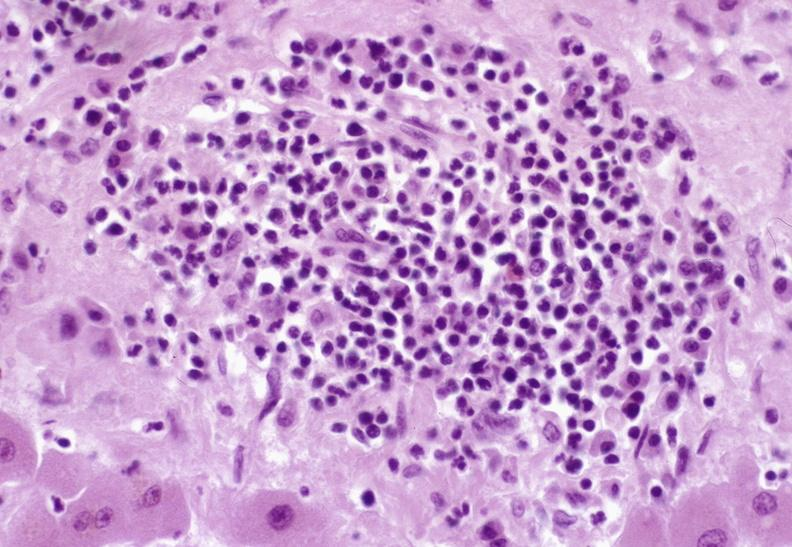what is present?
Answer the question using a single word or phrase. Hepatobiliary 